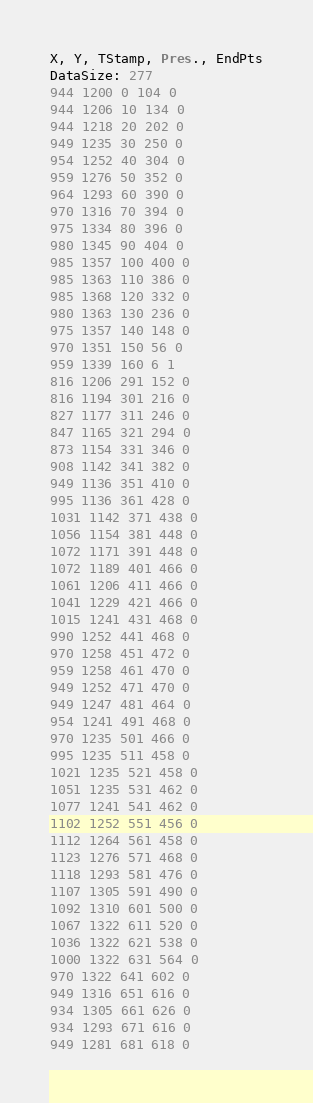Convert code to text. <code><loc_0><loc_0><loc_500><loc_500><_SML_>X, Y, TStamp, Pres., EndPts
DataSize: 277
944 1200 0 104 0
944 1206 10 134 0
944 1218 20 202 0
949 1235 30 250 0
954 1252 40 304 0
959 1276 50 352 0
964 1293 60 390 0
970 1316 70 394 0
975 1334 80 396 0
980 1345 90 404 0
985 1357 100 400 0
985 1363 110 386 0
985 1368 120 332 0
980 1363 130 236 0
975 1357 140 148 0
970 1351 150 56 0
959 1339 160 6 1
816 1206 291 152 0
816 1194 301 216 0
827 1177 311 246 0
847 1165 321 294 0
873 1154 331 346 0
908 1142 341 382 0
949 1136 351 410 0
995 1136 361 428 0
1031 1142 371 438 0
1056 1154 381 448 0
1072 1171 391 448 0
1072 1189 401 466 0
1061 1206 411 466 0
1041 1229 421 466 0
1015 1241 431 468 0
990 1252 441 468 0
970 1258 451 472 0
959 1258 461 470 0
949 1252 471 470 0
949 1247 481 464 0
954 1241 491 468 0
970 1235 501 466 0
995 1235 511 458 0
1021 1235 521 458 0
1051 1235 531 462 0
1077 1241 541 462 0
1102 1252 551 456 0
1112 1264 561 458 0
1123 1276 571 468 0
1118 1293 581 476 0
1107 1305 591 490 0
1092 1310 601 500 0
1067 1322 611 520 0
1036 1322 621 538 0
1000 1322 631 564 0
970 1322 641 602 0
949 1316 651 616 0
934 1305 661 626 0
934 1293 671 616 0
949 1281 681 618 0</code> 